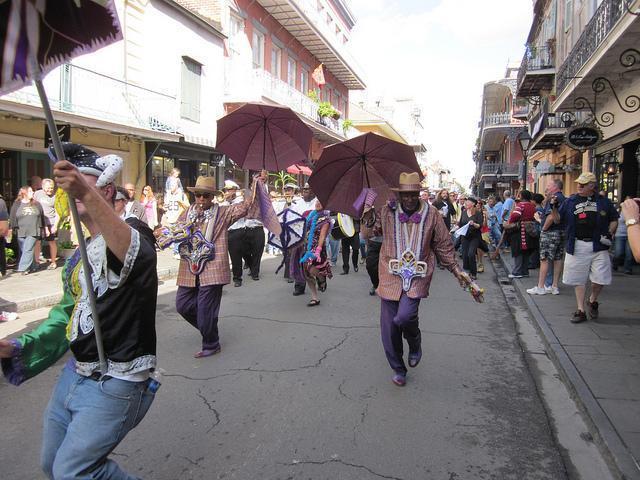What activity are people holding umbrellas taking part in?
Select the accurate answer and provide explanation: 'Answer: answer
Rationale: rationale.'
Options: Standing, fleeing, singing, parade. Answer: parade.
Rationale: The people are marching down the street and others are watching them. 